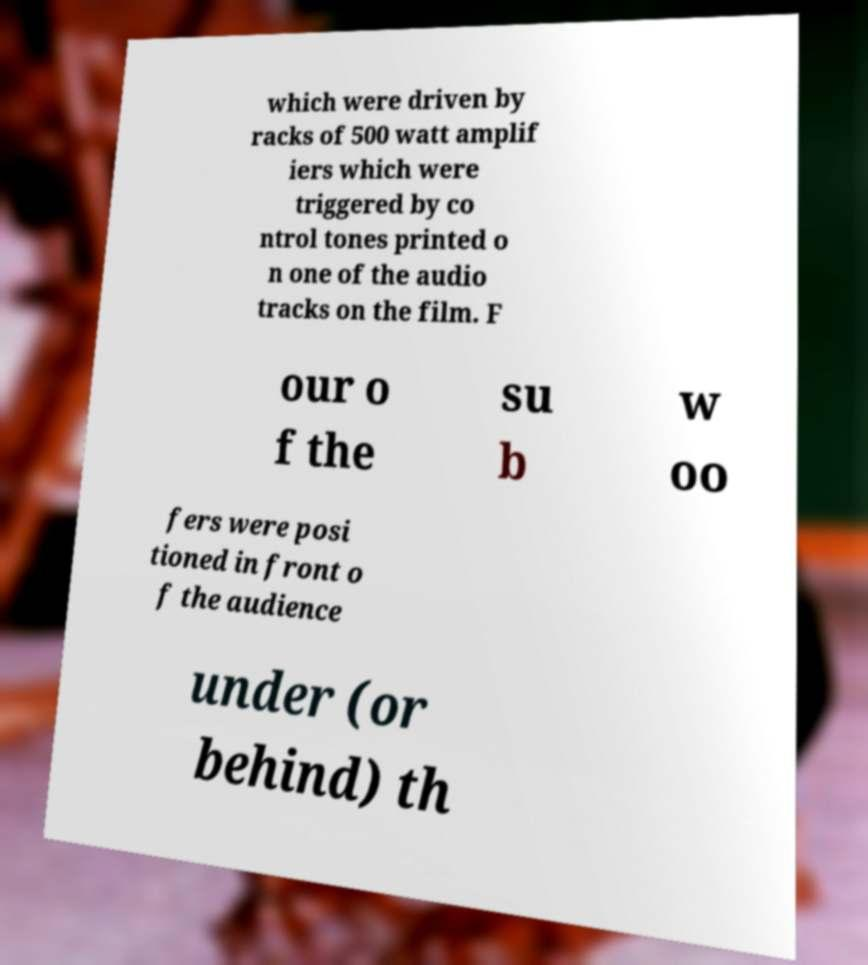There's text embedded in this image that I need extracted. Can you transcribe it verbatim? which were driven by racks of 500 watt amplif iers which were triggered by co ntrol tones printed o n one of the audio tracks on the film. F our o f the su b w oo fers were posi tioned in front o f the audience under (or behind) th 